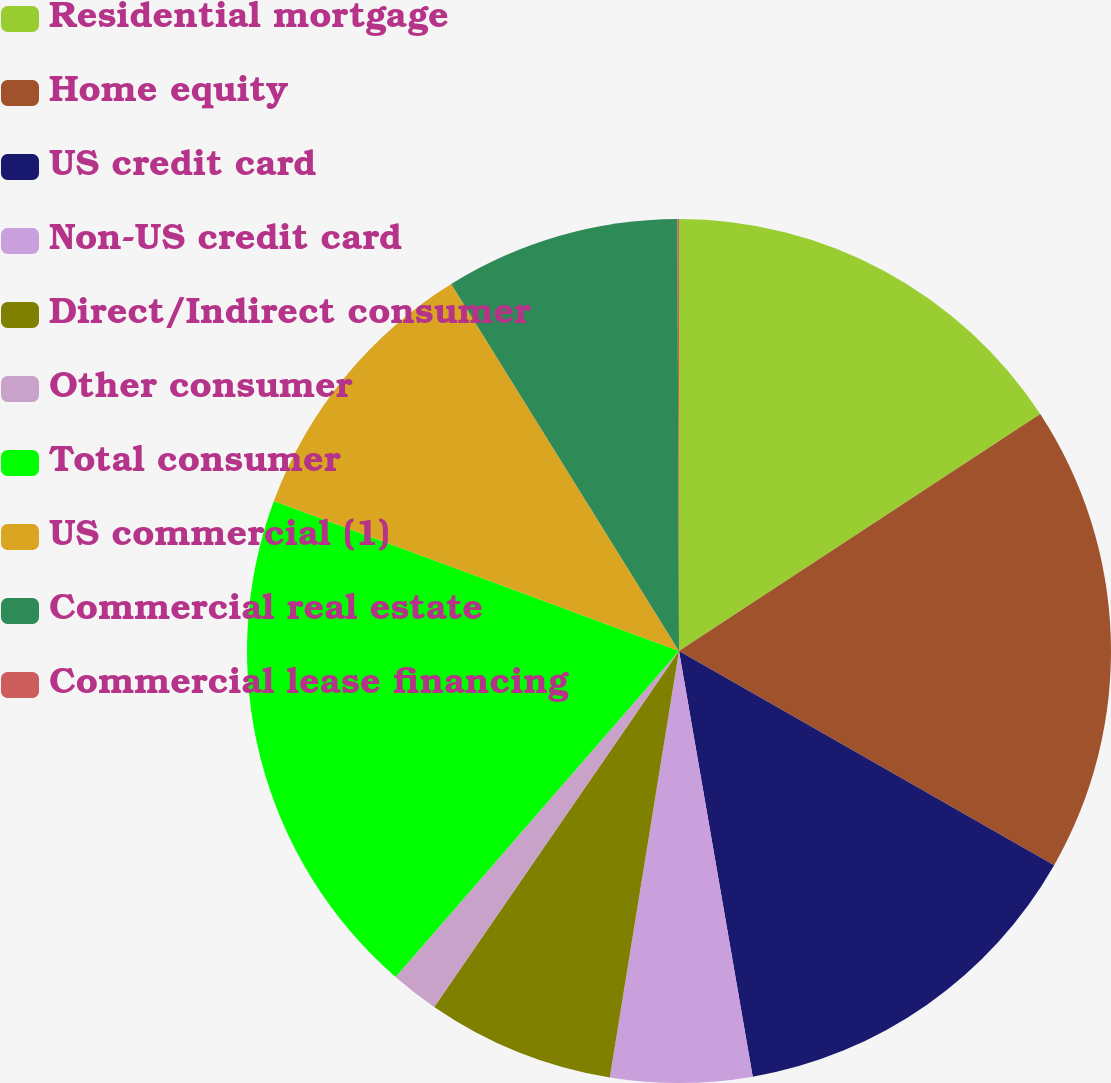Convert chart to OTSL. <chart><loc_0><loc_0><loc_500><loc_500><pie_chart><fcel>Residential mortgage<fcel>Home equity<fcel>US credit card<fcel>Non-US credit card<fcel>Direct/Indirect consumer<fcel>Other consumer<fcel>Total consumer<fcel>US commercial (1)<fcel>Commercial real estate<fcel>Commercial lease financing<nl><fcel>15.76%<fcel>17.5%<fcel>14.01%<fcel>5.29%<fcel>7.03%<fcel>1.8%<fcel>19.25%<fcel>10.52%<fcel>8.78%<fcel>0.06%<nl></chart> 